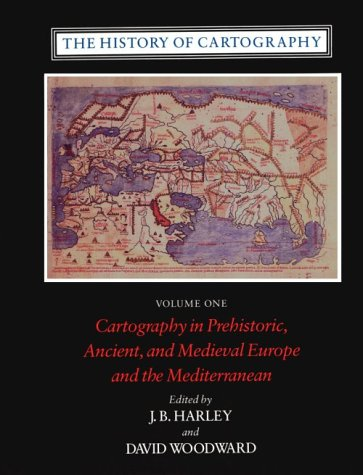Can you describe the map shown on the cover of this book? The map on the cover is a medieval European map, likely created in the era when cartographic science was grounded in both exploration and the academic studies of geography. It features various regions with colored boundaries, emphasizing the artistic style typical of that time. 